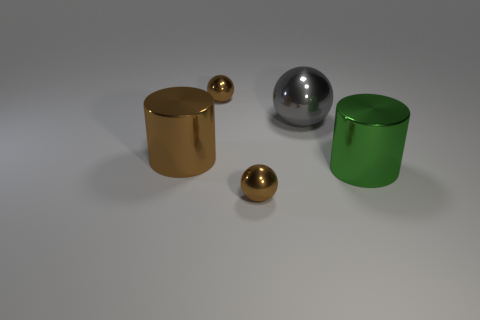What is the material of the tiny brown thing that is behind the large cylinder that is left of the big green metallic object?
Your answer should be compact. Metal. What number of other things are the same material as the green cylinder?
Keep it short and to the point. 4. What material is the other cylinder that is the same size as the green cylinder?
Your answer should be compact. Metal. Is the number of tiny shiny balls that are left of the large brown cylinder greater than the number of small metal balls behind the large gray metal object?
Your answer should be compact. No. Is there another big shiny object that has the same shape as the green metal thing?
Provide a succinct answer. Yes. The gray object that is the same size as the brown metallic cylinder is what shape?
Offer a very short reply. Sphere. What shape is the small shiny thing behind the brown metal cylinder?
Give a very brief answer. Sphere. Is the number of gray metallic spheres that are behind the big ball less than the number of metallic balls left of the green cylinder?
Your answer should be compact. Yes. Do the brown metal cylinder and the cylinder that is in front of the large brown shiny cylinder have the same size?
Give a very brief answer. Yes. How many green cylinders are the same size as the brown metal cylinder?
Provide a succinct answer. 1. 